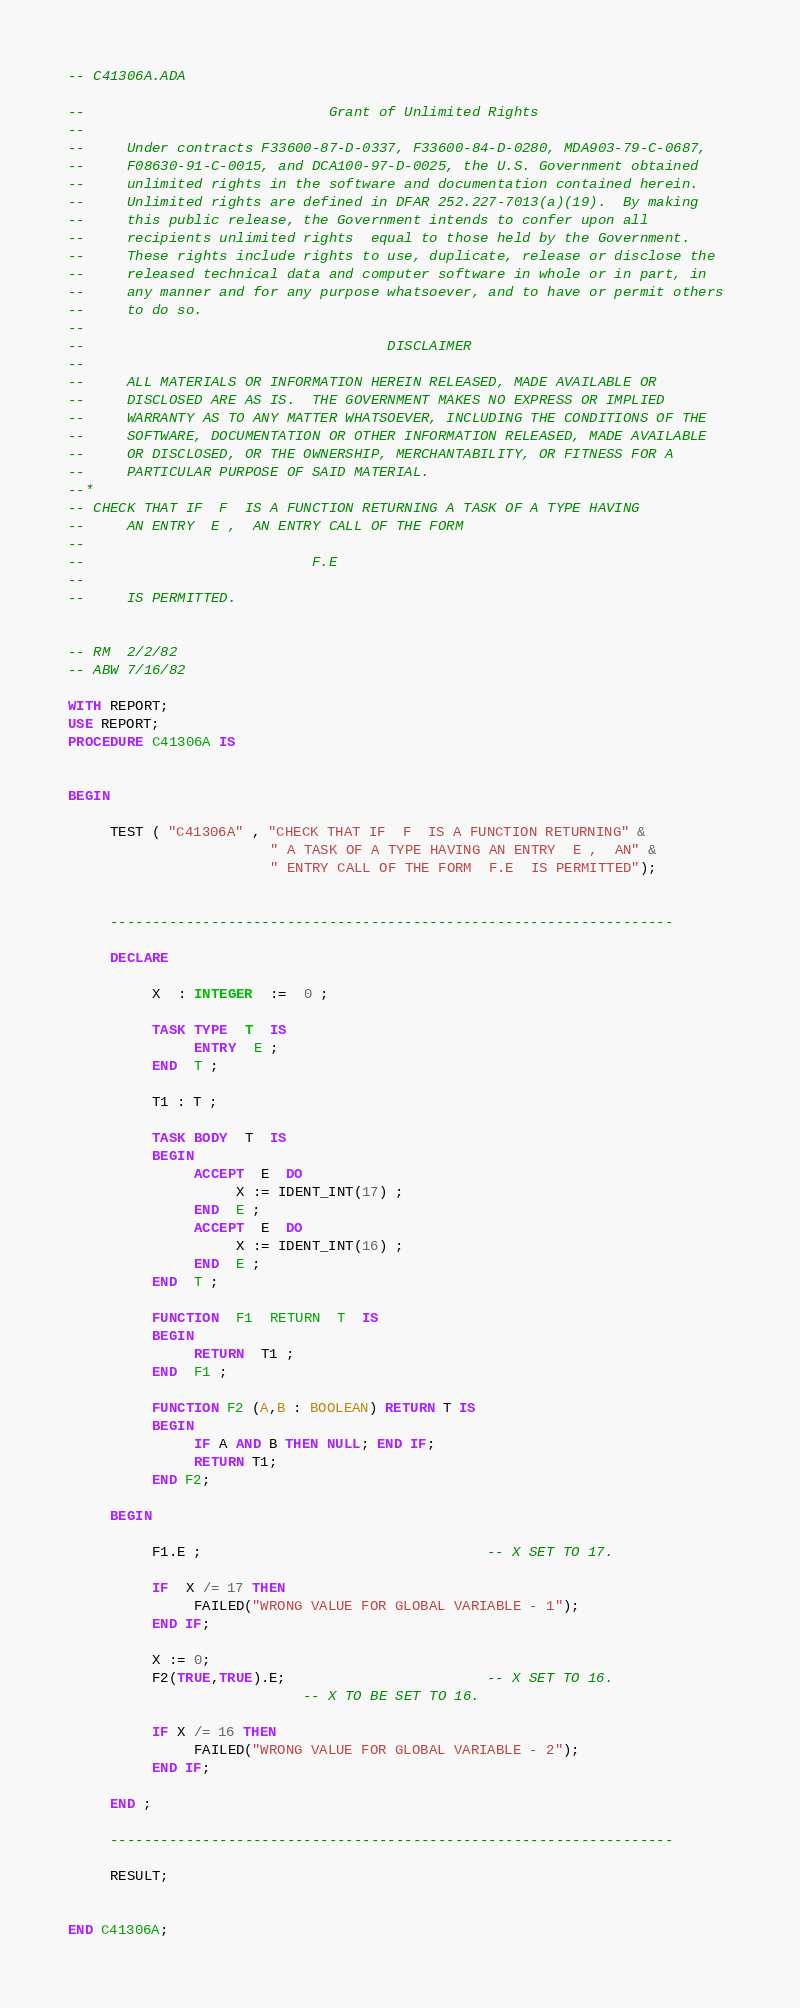Convert code to text. <code><loc_0><loc_0><loc_500><loc_500><_Ada_>-- C41306A.ADA

--                             Grant of Unlimited Rights
--
--     Under contracts F33600-87-D-0337, F33600-84-D-0280, MDA903-79-C-0687,
--     F08630-91-C-0015, and DCA100-97-D-0025, the U.S. Government obtained 
--     unlimited rights in the software and documentation contained herein.
--     Unlimited rights are defined in DFAR 252.227-7013(a)(19).  By making 
--     this public release, the Government intends to confer upon all 
--     recipients unlimited rights  equal to those held by the Government.  
--     These rights include rights to use, duplicate, release or disclose the 
--     released technical data and computer software in whole or in part, in 
--     any manner and for any purpose whatsoever, and to have or permit others 
--     to do so.
--
--                                    DISCLAIMER
--
--     ALL MATERIALS OR INFORMATION HEREIN RELEASED, MADE AVAILABLE OR
--     DISCLOSED ARE AS IS.  THE GOVERNMENT MAKES NO EXPRESS OR IMPLIED 
--     WARRANTY AS TO ANY MATTER WHATSOEVER, INCLUDING THE CONDITIONS OF THE
--     SOFTWARE, DOCUMENTATION OR OTHER INFORMATION RELEASED, MADE AVAILABLE 
--     OR DISCLOSED, OR THE OWNERSHIP, MERCHANTABILITY, OR FITNESS FOR A
--     PARTICULAR PURPOSE OF SAID MATERIAL.
--*
-- CHECK THAT IF  F  IS A FUNCTION RETURNING A TASK OF A TYPE HAVING
--     AN ENTRY  E ,  AN ENTRY CALL OF THE FORM
--
--                           F.E
--
--     IS PERMITTED.


-- RM  2/2/82
-- ABW 7/16/82

WITH REPORT;
USE REPORT;
PROCEDURE C41306A IS


BEGIN

     TEST ( "C41306A" , "CHECK THAT IF  F  IS A FUNCTION RETURNING" &
                        " A TASK OF A TYPE HAVING AN ENTRY  E ,  AN" &
                        " ENTRY CALL OF THE FORM  F.E  IS PERMITTED");


     -------------------------------------------------------------------

     DECLARE

          X  : INTEGER  :=  0 ;

          TASK TYPE  T  IS
               ENTRY  E ;
          END  T ;

          T1 : T ;

          TASK BODY  T  IS
          BEGIN
               ACCEPT  E  DO
                    X := IDENT_INT(17) ;
               END  E ;
               ACCEPT  E  DO
                    X := IDENT_INT(16) ;
               END  E ;
          END  T ;

          FUNCTION  F1  RETURN  T  IS
          BEGIN
               RETURN  T1 ;
          END  F1 ;

          FUNCTION F2 (A,B : BOOLEAN) RETURN T IS
          BEGIN
               IF A AND B THEN NULL; END IF;
               RETURN T1;
          END F2;

     BEGIN

          F1.E ;                                  -- X SET TO 17.

          IF  X /= 17 THEN
               FAILED("WRONG VALUE FOR GLOBAL VARIABLE - 1");
          END IF;

          X := 0;
          F2(TRUE,TRUE).E;                        -- X SET TO 16.
                            -- X TO BE SET TO 16.

          IF X /= 16 THEN
               FAILED("WRONG VALUE FOR GLOBAL VARIABLE - 2");
          END IF;

     END ;

     -------------------------------------------------------------------

     RESULT;


END C41306A;
</code> 